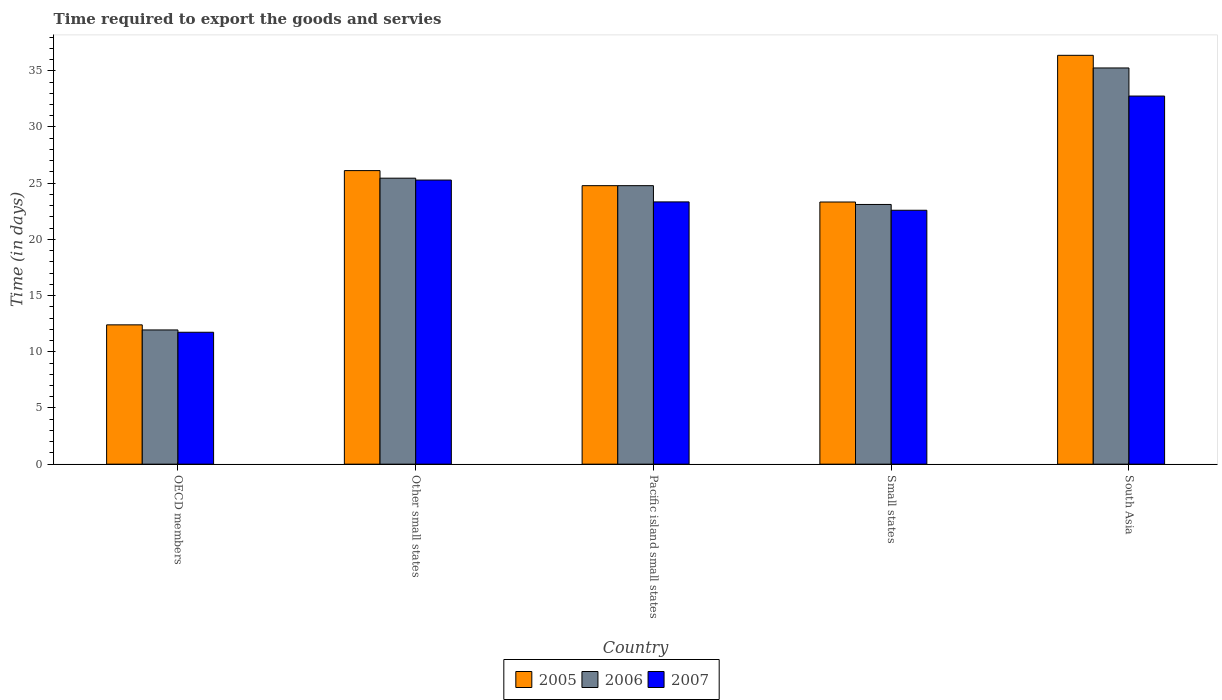Are the number of bars on each tick of the X-axis equal?
Make the answer very short. Yes. What is the label of the 4th group of bars from the left?
Provide a succinct answer. Small states. In how many cases, is the number of bars for a given country not equal to the number of legend labels?
Offer a very short reply. 0. What is the number of days required to export the goods and services in 2007 in South Asia?
Your answer should be compact. 32.75. Across all countries, what is the maximum number of days required to export the goods and services in 2007?
Your answer should be compact. 32.75. Across all countries, what is the minimum number of days required to export the goods and services in 2006?
Offer a very short reply. 11.94. In which country was the number of days required to export the goods and services in 2006 maximum?
Ensure brevity in your answer.  South Asia. What is the total number of days required to export the goods and services in 2006 in the graph?
Provide a short and direct response. 120.52. What is the difference between the number of days required to export the goods and services in 2005 in Other small states and that in Small states?
Provide a short and direct response. 2.79. What is the difference between the number of days required to export the goods and services in 2007 in Pacific island small states and the number of days required to export the goods and services in 2006 in OECD members?
Offer a terse response. 11.39. What is the average number of days required to export the goods and services in 2005 per country?
Your response must be concise. 24.6. What is the difference between the number of days required to export the goods and services of/in 2007 and number of days required to export the goods and services of/in 2006 in Other small states?
Your answer should be very brief. -0.17. What is the ratio of the number of days required to export the goods and services in 2006 in Pacific island small states to that in South Asia?
Offer a terse response. 0.7. Is the number of days required to export the goods and services in 2007 in Other small states less than that in South Asia?
Ensure brevity in your answer.  Yes. What is the difference between the highest and the second highest number of days required to export the goods and services in 2007?
Keep it short and to the point. 7.47. What is the difference between the highest and the lowest number of days required to export the goods and services in 2005?
Offer a very short reply. 23.98. Is the sum of the number of days required to export the goods and services in 2007 in OECD members and Pacific island small states greater than the maximum number of days required to export the goods and services in 2005 across all countries?
Offer a terse response. No. What does the 3rd bar from the right in Pacific island small states represents?
Offer a terse response. 2005. Is it the case that in every country, the sum of the number of days required to export the goods and services in 2005 and number of days required to export the goods and services in 2007 is greater than the number of days required to export the goods and services in 2006?
Your answer should be very brief. Yes. Are all the bars in the graph horizontal?
Provide a succinct answer. No. How many countries are there in the graph?
Offer a very short reply. 5. What is the difference between two consecutive major ticks on the Y-axis?
Keep it short and to the point. 5. Are the values on the major ticks of Y-axis written in scientific E-notation?
Your answer should be compact. No. Does the graph contain any zero values?
Your answer should be compact. No. Does the graph contain grids?
Give a very brief answer. No. How are the legend labels stacked?
Offer a terse response. Horizontal. What is the title of the graph?
Offer a very short reply. Time required to export the goods and servies. Does "1987" appear as one of the legend labels in the graph?
Provide a succinct answer. No. What is the label or title of the X-axis?
Provide a short and direct response. Country. What is the label or title of the Y-axis?
Give a very brief answer. Time (in days). What is the Time (in days) in 2005 in OECD members?
Your answer should be very brief. 12.39. What is the Time (in days) in 2006 in OECD members?
Offer a very short reply. 11.94. What is the Time (in days) of 2007 in OECD members?
Offer a terse response. 11.74. What is the Time (in days) in 2005 in Other small states?
Make the answer very short. 26.12. What is the Time (in days) of 2006 in Other small states?
Offer a terse response. 25.44. What is the Time (in days) of 2007 in Other small states?
Provide a short and direct response. 25.28. What is the Time (in days) in 2005 in Pacific island small states?
Provide a short and direct response. 24.78. What is the Time (in days) of 2006 in Pacific island small states?
Your response must be concise. 24.78. What is the Time (in days) in 2007 in Pacific island small states?
Give a very brief answer. 23.33. What is the Time (in days) of 2005 in Small states?
Make the answer very short. 23.32. What is the Time (in days) in 2006 in Small states?
Your answer should be compact. 23.11. What is the Time (in days) of 2007 in Small states?
Provide a short and direct response. 22.59. What is the Time (in days) in 2005 in South Asia?
Your answer should be compact. 36.38. What is the Time (in days) of 2006 in South Asia?
Provide a short and direct response. 35.25. What is the Time (in days) in 2007 in South Asia?
Give a very brief answer. 32.75. Across all countries, what is the maximum Time (in days) of 2005?
Give a very brief answer. 36.38. Across all countries, what is the maximum Time (in days) of 2006?
Provide a short and direct response. 35.25. Across all countries, what is the maximum Time (in days) in 2007?
Your answer should be very brief. 32.75. Across all countries, what is the minimum Time (in days) of 2005?
Ensure brevity in your answer.  12.39. Across all countries, what is the minimum Time (in days) of 2006?
Keep it short and to the point. 11.94. Across all countries, what is the minimum Time (in days) in 2007?
Offer a terse response. 11.74. What is the total Time (in days) in 2005 in the graph?
Offer a terse response. 122.99. What is the total Time (in days) of 2006 in the graph?
Give a very brief answer. 120.52. What is the total Time (in days) in 2007 in the graph?
Your response must be concise. 115.69. What is the difference between the Time (in days) of 2005 in OECD members and that in Other small states?
Your response must be concise. -13.72. What is the difference between the Time (in days) in 2006 in OECD members and that in Other small states?
Your answer should be very brief. -13.5. What is the difference between the Time (in days) in 2007 in OECD members and that in Other small states?
Your response must be concise. -13.54. What is the difference between the Time (in days) of 2005 in OECD members and that in Pacific island small states?
Give a very brief answer. -12.38. What is the difference between the Time (in days) of 2006 in OECD members and that in Pacific island small states?
Offer a terse response. -12.84. What is the difference between the Time (in days) of 2007 in OECD members and that in Pacific island small states?
Your response must be concise. -11.6. What is the difference between the Time (in days) in 2005 in OECD members and that in Small states?
Provide a short and direct response. -10.93. What is the difference between the Time (in days) in 2006 in OECD members and that in Small states?
Provide a succinct answer. -11.16. What is the difference between the Time (in days) in 2007 in OECD members and that in Small states?
Give a very brief answer. -10.85. What is the difference between the Time (in days) in 2005 in OECD members and that in South Asia?
Make the answer very short. -23.98. What is the difference between the Time (in days) in 2006 in OECD members and that in South Asia?
Provide a short and direct response. -23.31. What is the difference between the Time (in days) in 2007 in OECD members and that in South Asia?
Offer a terse response. -21.01. What is the difference between the Time (in days) in 2005 in Other small states and that in Pacific island small states?
Your answer should be very brief. 1.34. What is the difference between the Time (in days) of 2006 in Other small states and that in Pacific island small states?
Provide a succinct answer. 0.67. What is the difference between the Time (in days) in 2007 in Other small states and that in Pacific island small states?
Provide a short and direct response. 1.94. What is the difference between the Time (in days) in 2005 in Other small states and that in Small states?
Your response must be concise. 2.79. What is the difference between the Time (in days) in 2006 in Other small states and that in Small states?
Give a very brief answer. 2.34. What is the difference between the Time (in days) in 2007 in Other small states and that in Small states?
Ensure brevity in your answer.  2.69. What is the difference between the Time (in days) in 2005 in Other small states and that in South Asia?
Offer a terse response. -10.26. What is the difference between the Time (in days) of 2006 in Other small states and that in South Asia?
Keep it short and to the point. -9.81. What is the difference between the Time (in days) of 2007 in Other small states and that in South Asia?
Your answer should be compact. -7.47. What is the difference between the Time (in days) in 2005 in Pacific island small states and that in Small states?
Offer a very short reply. 1.45. What is the difference between the Time (in days) of 2006 in Pacific island small states and that in Small states?
Provide a short and direct response. 1.67. What is the difference between the Time (in days) in 2007 in Pacific island small states and that in Small states?
Your answer should be compact. 0.74. What is the difference between the Time (in days) of 2005 in Pacific island small states and that in South Asia?
Provide a short and direct response. -11.6. What is the difference between the Time (in days) of 2006 in Pacific island small states and that in South Asia?
Offer a very short reply. -10.47. What is the difference between the Time (in days) of 2007 in Pacific island small states and that in South Asia?
Your answer should be very brief. -9.42. What is the difference between the Time (in days) of 2005 in Small states and that in South Asia?
Provide a succinct answer. -13.05. What is the difference between the Time (in days) in 2006 in Small states and that in South Asia?
Your answer should be compact. -12.14. What is the difference between the Time (in days) of 2007 in Small states and that in South Asia?
Your answer should be very brief. -10.16. What is the difference between the Time (in days) in 2005 in OECD members and the Time (in days) in 2006 in Other small states?
Ensure brevity in your answer.  -13.05. What is the difference between the Time (in days) in 2005 in OECD members and the Time (in days) in 2007 in Other small states?
Ensure brevity in your answer.  -12.88. What is the difference between the Time (in days) of 2006 in OECD members and the Time (in days) of 2007 in Other small states?
Provide a short and direct response. -13.34. What is the difference between the Time (in days) of 2005 in OECD members and the Time (in days) of 2006 in Pacific island small states?
Your answer should be very brief. -12.38. What is the difference between the Time (in days) in 2005 in OECD members and the Time (in days) in 2007 in Pacific island small states?
Provide a succinct answer. -10.94. What is the difference between the Time (in days) in 2006 in OECD members and the Time (in days) in 2007 in Pacific island small states?
Your response must be concise. -11.39. What is the difference between the Time (in days) in 2005 in OECD members and the Time (in days) in 2006 in Small states?
Your response must be concise. -10.71. What is the difference between the Time (in days) in 2005 in OECD members and the Time (in days) in 2007 in Small states?
Your response must be concise. -10.2. What is the difference between the Time (in days) of 2006 in OECD members and the Time (in days) of 2007 in Small states?
Offer a very short reply. -10.65. What is the difference between the Time (in days) in 2005 in OECD members and the Time (in days) in 2006 in South Asia?
Your response must be concise. -22.86. What is the difference between the Time (in days) in 2005 in OECD members and the Time (in days) in 2007 in South Asia?
Offer a terse response. -20.36. What is the difference between the Time (in days) of 2006 in OECD members and the Time (in days) of 2007 in South Asia?
Your answer should be compact. -20.81. What is the difference between the Time (in days) in 2005 in Other small states and the Time (in days) in 2006 in Pacific island small states?
Your answer should be compact. 1.34. What is the difference between the Time (in days) of 2005 in Other small states and the Time (in days) of 2007 in Pacific island small states?
Provide a short and direct response. 2.78. What is the difference between the Time (in days) in 2006 in Other small states and the Time (in days) in 2007 in Pacific island small states?
Provide a short and direct response. 2.11. What is the difference between the Time (in days) of 2005 in Other small states and the Time (in days) of 2006 in Small states?
Make the answer very short. 3.01. What is the difference between the Time (in days) of 2005 in Other small states and the Time (in days) of 2007 in Small states?
Provide a short and direct response. 3.53. What is the difference between the Time (in days) in 2006 in Other small states and the Time (in days) in 2007 in Small states?
Make the answer very short. 2.85. What is the difference between the Time (in days) of 2005 in Other small states and the Time (in days) of 2006 in South Asia?
Ensure brevity in your answer.  -9.13. What is the difference between the Time (in days) in 2005 in Other small states and the Time (in days) in 2007 in South Asia?
Give a very brief answer. -6.63. What is the difference between the Time (in days) in 2006 in Other small states and the Time (in days) in 2007 in South Asia?
Offer a very short reply. -7.31. What is the difference between the Time (in days) in 2005 in Pacific island small states and the Time (in days) in 2006 in Small states?
Make the answer very short. 1.67. What is the difference between the Time (in days) in 2005 in Pacific island small states and the Time (in days) in 2007 in Small states?
Your response must be concise. 2.19. What is the difference between the Time (in days) of 2006 in Pacific island small states and the Time (in days) of 2007 in Small states?
Offer a terse response. 2.19. What is the difference between the Time (in days) of 2005 in Pacific island small states and the Time (in days) of 2006 in South Asia?
Keep it short and to the point. -10.47. What is the difference between the Time (in days) in 2005 in Pacific island small states and the Time (in days) in 2007 in South Asia?
Your answer should be very brief. -7.97. What is the difference between the Time (in days) in 2006 in Pacific island small states and the Time (in days) in 2007 in South Asia?
Provide a succinct answer. -7.97. What is the difference between the Time (in days) in 2005 in Small states and the Time (in days) in 2006 in South Asia?
Provide a succinct answer. -11.93. What is the difference between the Time (in days) in 2005 in Small states and the Time (in days) in 2007 in South Asia?
Offer a terse response. -9.43. What is the difference between the Time (in days) of 2006 in Small states and the Time (in days) of 2007 in South Asia?
Your response must be concise. -9.64. What is the average Time (in days) of 2005 per country?
Offer a terse response. 24.6. What is the average Time (in days) of 2006 per country?
Offer a very short reply. 24.1. What is the average Time (in days) of 2007 per country?
Give a very brief answer. 23.14. What is the difference between the Time (in days) of 2005 and Time (in days) of 2006 in OECD members?
Keep it short and to the point. 0.45. What is the difference between the Time (in days) of 2005 and Time (in days) of 2007 in OECD members?
Your response must be concise. 0.66. What is the difference between the Time (in days) of 2006 and Time (in days) of 2007 in OECD members?
Offer a terse response. 0.21. What is the difference between the Time (in days) in 2005 and Time (in days) in 2006 in Other small states?
Give a very brief answer. 0.67. What is the difference between the Time (in days) of 2005 and Time (in days) of 2007 in Other small states?
Provide a succinct answer. 0.84. What is the difference between the Time (in days) of 2005 and Time (in days) of 2006 in Pacific island small states?
Give a very brief answer. 0. What is the difference between the Time (in days) of 2005 and Time (in days) of 2007 in Pacific island small states?
Your answer should be very brief. 1.44. What is the difference between the Time (in days) in 2006 and Time (in days) in 2007 in Pacific island small states?
Offer a terse response. 1.44. What is the difference between the Time (in days) of 2005 and Time (in days) of 2006 in Small states?
Your answer should be very brief. 0.22. What is the difference between the Time (in days) of 2005 and Time (in days) of 2007 in Small states?
Make the answer very short. 0.73. What is the difference between the Time (in days) in 2006 and Time (in days) in 2007 in Small states?
Keep it short and to the point. 0.52. What is the difference between the Time (in days) of 2005 and Time (in days) of 2007 in South Asia?
Keep it short and to the point. 3.62. What is the ratio of the Time (in days) of 2005 in OECD members to that in Other small states?
Provide a short and direct response. 0.47. What is the ratio of the Time (in days) of 2006 in OECD members to that in Other small states?
Your response must be concise. 0.47. What is the ratio of the Time (in days) in 2007 in OECD members to that in Other small states?
Keep it short and to the point. 0.46. What is the ratio of the Time (in days) in 2005 in OECD members to that in Pacific island small states?
Your response must be concise. 0.5. What is the ratio of the Time (in days) of 2006 in OECD members to that in Pacific island small states?
Your answer should be compact. 0.48. What is the ratio of the Time (in days) in 2007 in OECD members to that in Pacific island small states?
Keep it short and to the point. 0.5. What is the ratio of the Time (in days) of 2005 in OECD members to that in Small states?
Keep it short and to the point. 0.53. What is the ratio of the Time (in days) in 2006 in OECD members to that in Small states?
Provide a succinct answer. 0.52. What is the ratio of the Time (in days) of 2007 in OECD members to that in Small states?
Offer a very short reply. 0.52. What is the ratio of the Time (in days) in 2005 in OECD members to that in South Asia?
Give a very brief answer. 0.34. What is the ratio of the Time (in days) in 2006 in OECD members to that in South Asia?
Make the answer very short. 0.34. What is the ratio of the Time (in days) of 2007 in OECD members to that in South Asia?
Provide a short and direct response. 0.36. What is the ratio of the Time (in days) in 2005 in Other small states to that in Pacific island small states?
Ensure brevity in your answer.  1.05. What is the ratio of the Time (in days) in 2006 in Other small states to that in Pacific island small states?
Your answer should be compact. 1.03. What is the ratio of the Time (in days) of 2007 in Other small states to that in Pacific island small states?
Ensure brevity in your answer.  1.08. What is the ratio of the Time (in days) in 2005 in Other small states to that in Small states?
Provide a succinct answer. 1.12. What is the ratio of the Time (in days) of 2006 in Other small states to that in Small states?
Provide a succinct answer. 1.1. What is the ratio of the Time (in days) in 2007 in Other small states to that in Small states?
Your answer should be compact. 1.12. What is the ratio of the Time (in days) of 2005 in Other small states to that in South Asia?
Offer a terse response. 0.72. What is the ratio of the Time (in days) of 2006 in Other small states to that in South Asia?
Provide a short and direct response. 0.72. What is the ratio of the Time (in days) of 2007 in Other small states to that in South Asia?
Give a very brief answer. 0.77. What is the ratio of the Time (in days) in 2005 in Pacific island small states to that in Small states?
Give a very brief answer. 1.06. What is the ratio of the Time (in days) in 2006 in Pacific island small states to that in Small states?
Offer a very short reply. 1.07. What is the ratio of the Time (in days) of 2007 in Pacific island small states to that in Small states?
Your answer should be very brief. 1.03. What is the ratio of the Time (in days) of 2005 in Pacific island small states to that in South Asia?
Offer a terse response. 0.68. What is the ratio of the Time (in days) in 2006 in Pacific island small states to that in South Asia?
Offer a terse response. 0.7. What is the ratio of the Time (in days) in 2007 in Pacific island small states to that in South Asia?
Your answer should be very brief. 0.71. What is the ratio of the Time (in days) in 2005 in Small states to that in South Asia?
Your response must be concise. 0.64. What is the ratio of the Time (in days) in 2006 in Small states to that in South Asia?
Your response must be concise. 0.66. What is the ratio of the Time (in days) of 2007 in Small states to that in South Asia?
Your response must be concise. 0.69. What is the difference between the highest and the second highest Time (in days) of 2005?
Your answer should be compact. 10.26. What is the difference between the highest and the second highest Time (in days) in 2006?
Offer a terse response. 9.81. What is the difference between the highest and the second highest Time (in days) in 2007?
Your answer should be very brief. 7.47. What is the difference between the highest and the lowest Time (in days) of 2005?
Make the answer very short. 23.98. What is the difference between the highest and the lowest Time (in days) of 2006?
Provide a succinct answer. 23.31. What is the difference between the highest and the lowest Time (in days) in 2007?
Provide a succinct answer. 21.01. 